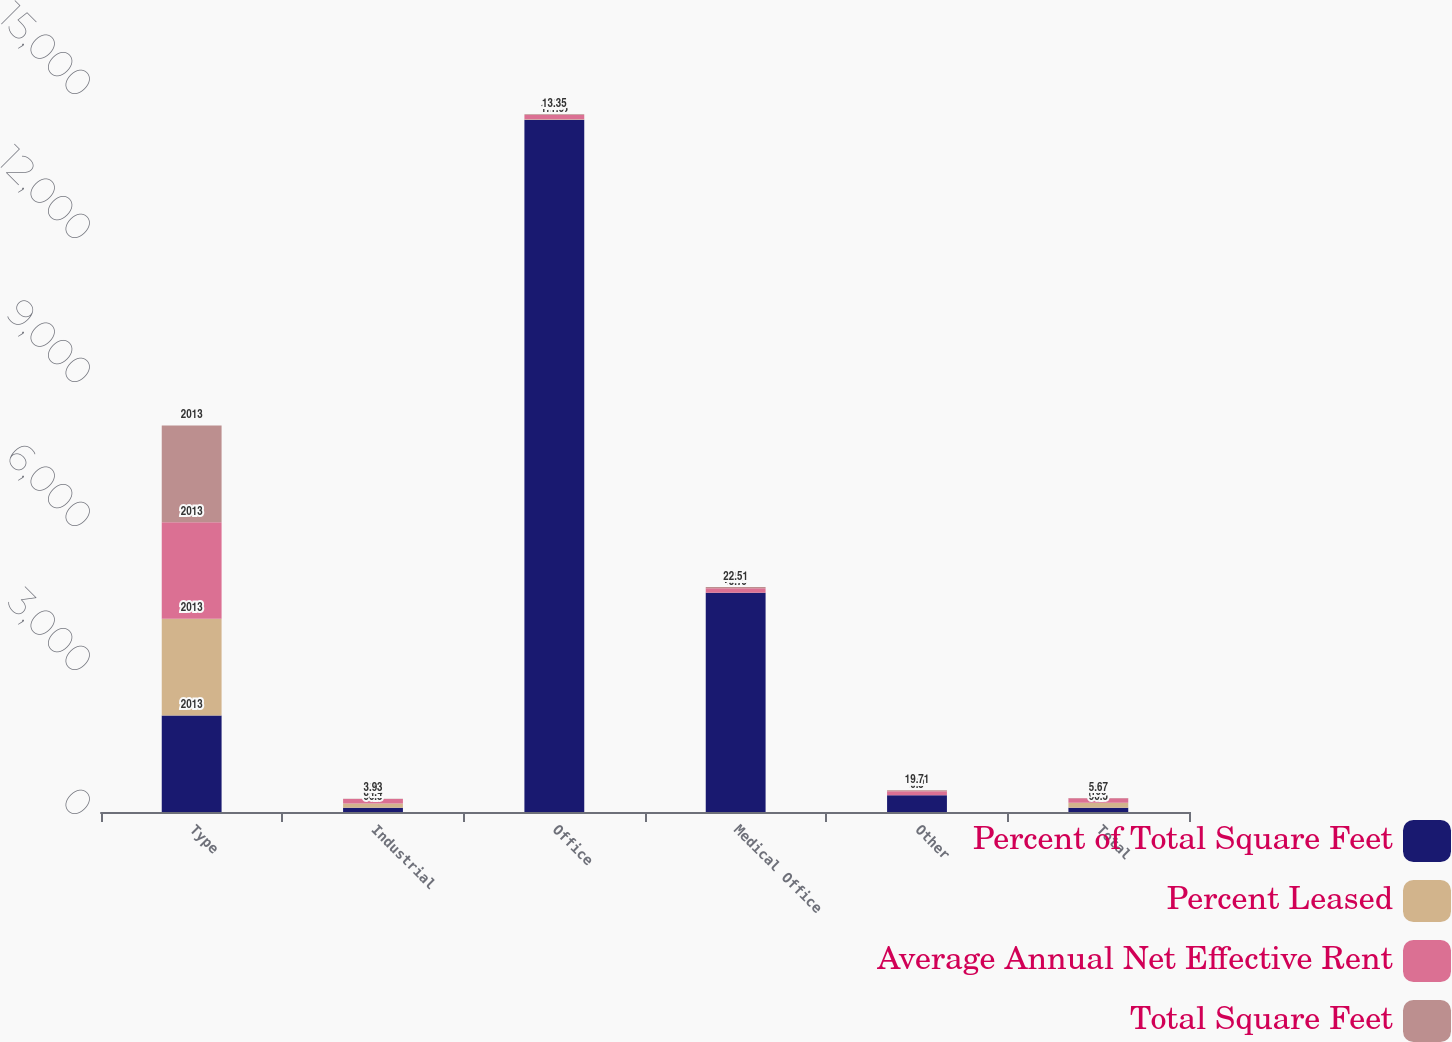<chart> <loc_0><loc_0><loc_500><loc_500><stacked_bar_chart><ecel><fcel>Type<fcel>Industrial<fcel>Office<fcel>Medical Office<fcel>Other<fcel>Total<nl><fcel>Percent of Total Square Feet<fcel>2013<fcel>90.5<fcel>14423<fcel>4566<fcel>348<fcel>90.5<nl><fcel>Percent Leased<fcel>2013<fcel>84.4<fcel>11.6<fcel>3.7<fcel>0.3<fcel>100<nl><fcel>Average Annual Net Effective Rent<fcel>2013<fcel>95<fcel>87.8<fcel>93.2<fcel>85.7<fcel>94.1<nl><fcel>Total Square Feet<fcel>2013<fcel>3.93<fcel>13.35<fcel>22.51<fcel>19.71<fcel>5.67<nl></chart> 